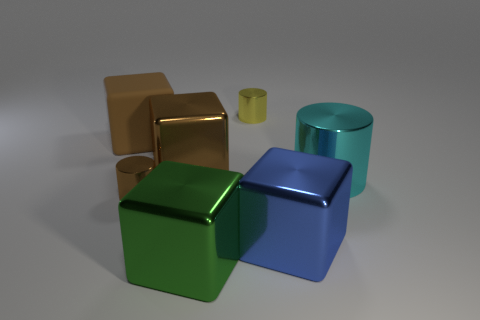Add 2 green objects. How many objects exist? 9 Subtract all cylinders. How many objects are left? 4 Subtract 0 gray cylinders. How many objects are left? 7 Subtract all green metal spheres. Subtract all large matte cubes. How many objects are left? 6 Add 5 large rubber objects. How many large rubber objects are left? 6 Add 1 big brown objects. How many big brown objects exist? 3 